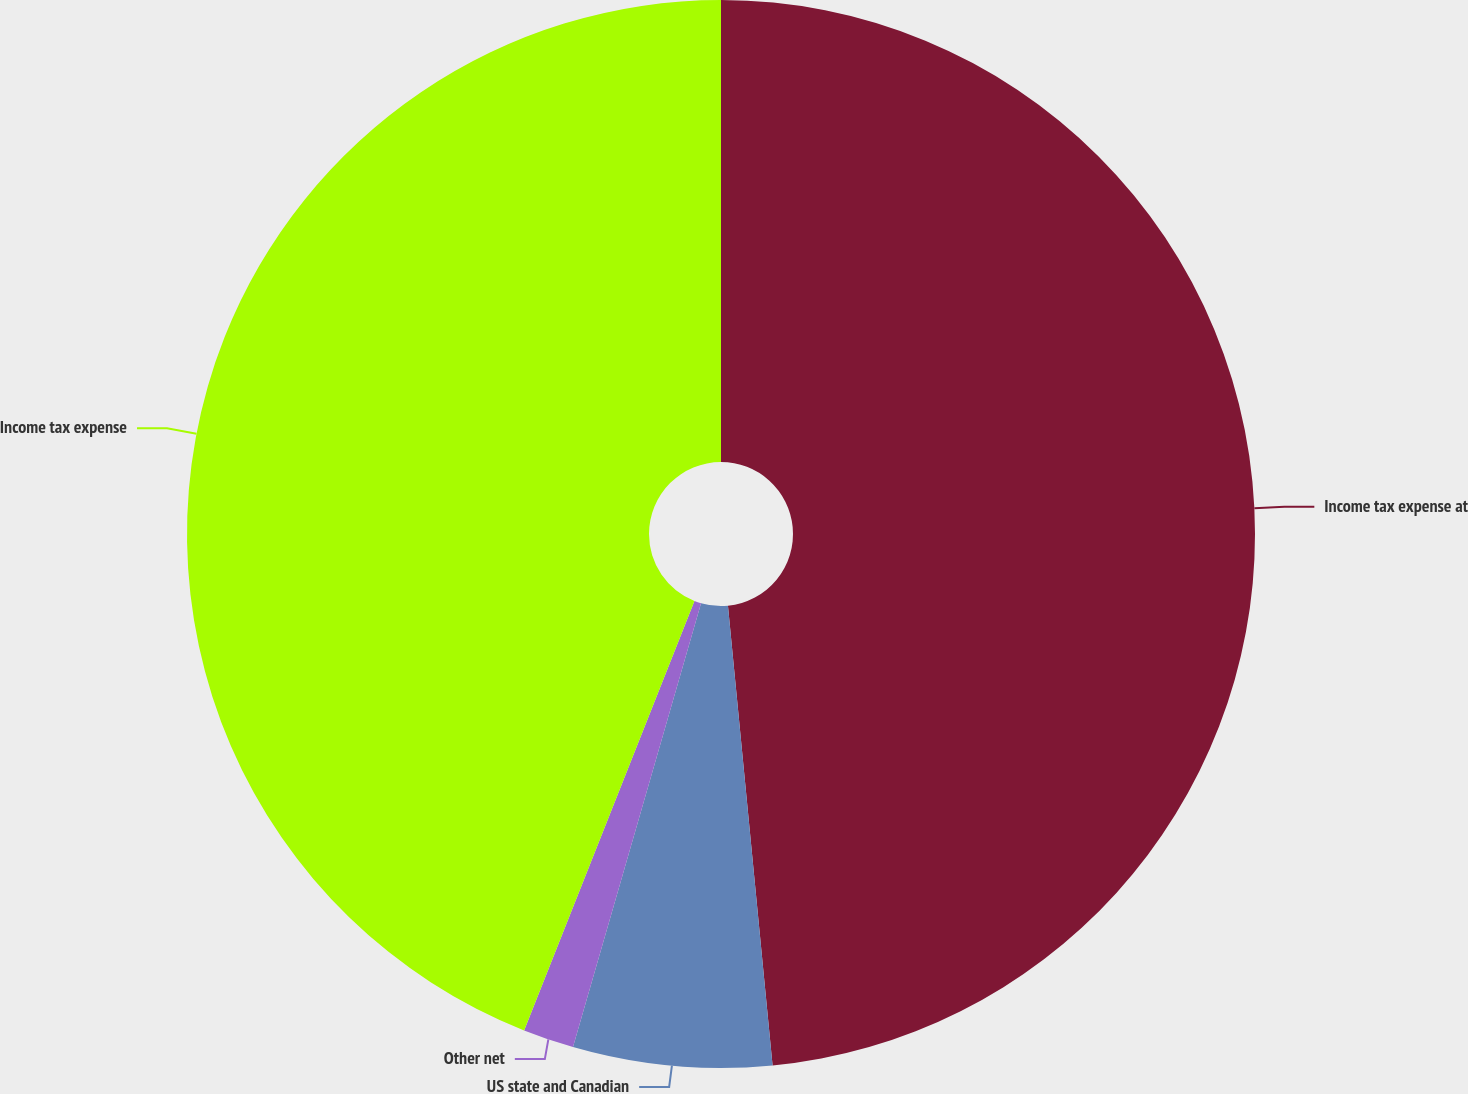Convert chart to OTSL. <chart><loc_0><loc_0><loc_500><loc_500><pie_chart><fcel>Income tax expense at<fcel>US state and Canadian<fcel>Other net<fcel>Income tax expense<nl><fcel>48.46%<fcel>6.01%<fcel>1.54%<fcel>43.99%<nl></chart> 